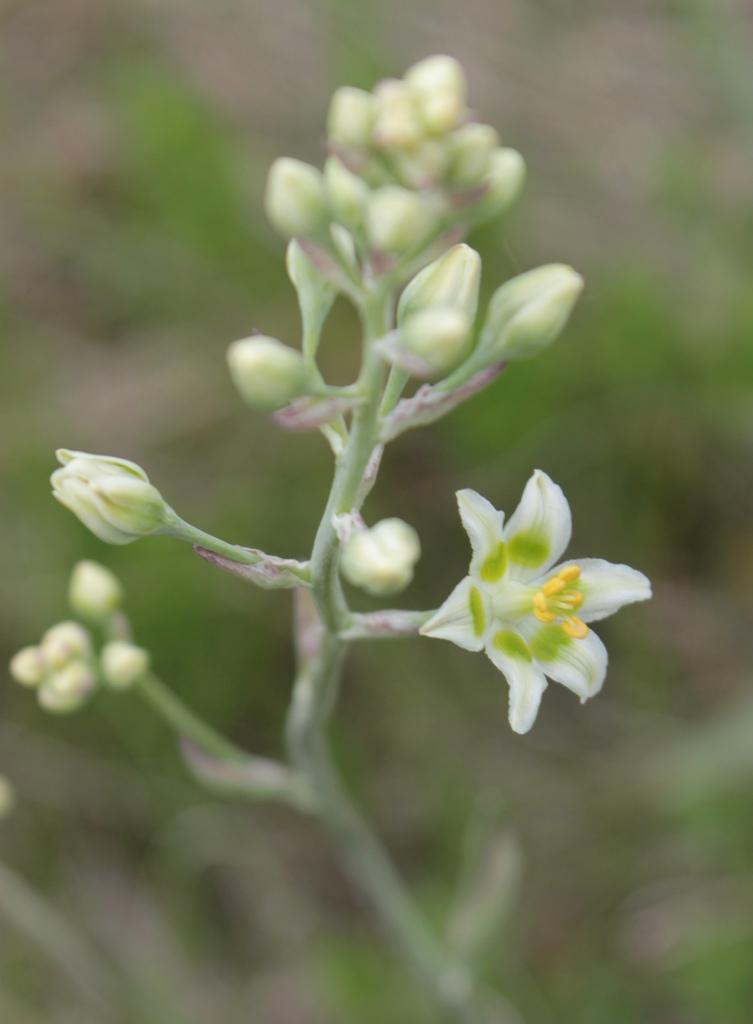What type of flower is in the image? There is a white flower in the image. What stage of growth are the flower's buds in? The flower has buds. What color is the background in the image? The background is green in color. How is the background depicted in the image? The background is blurred. What type of development or organization is depicted in the image? There is no development or organization present in the image; it features a white flower with buds against a green, blurred background. 